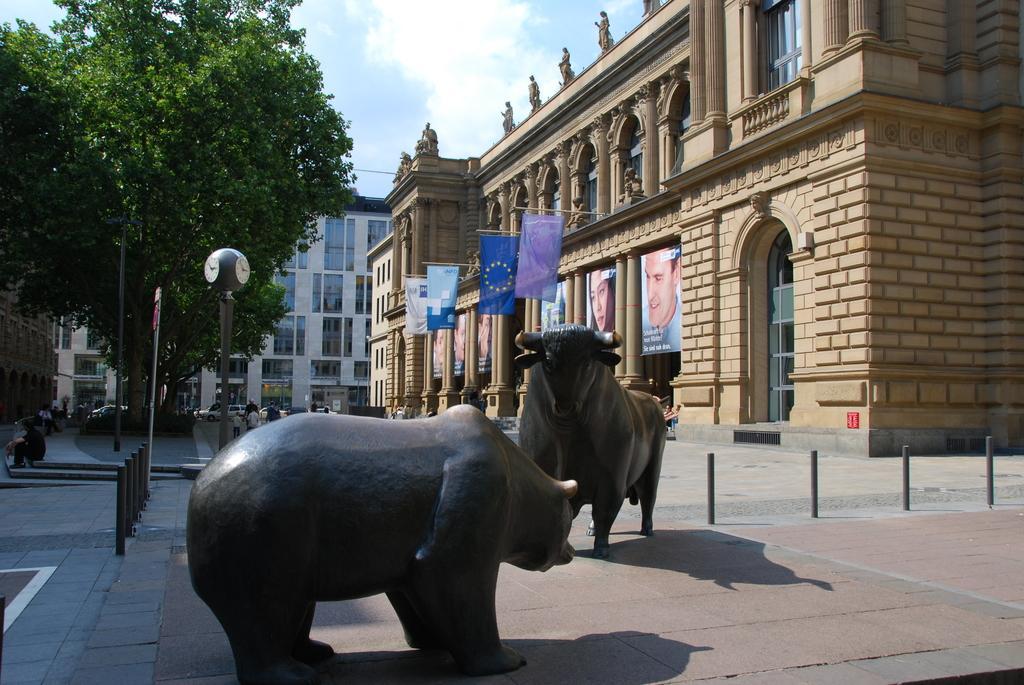How would you summarize this image in a sentence or two? In this image we can see the depiction of animals on the land. We can also see the fencing rods, sign board pole and some other pole on the left. We can also see the buildings with banners and also hoardings and statues. We can also see the trees and also the vehicles and a few people. At the top there is sky with the clouds. 